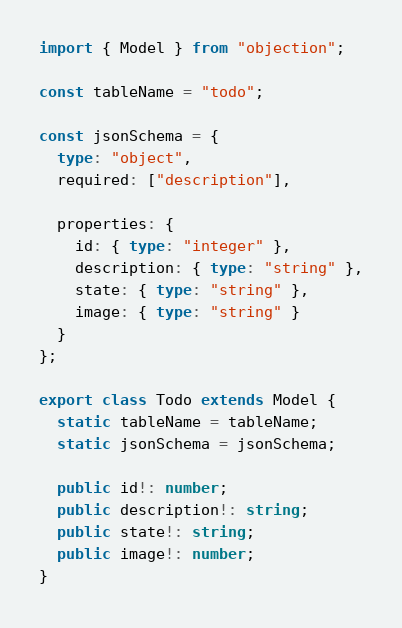<code> <loc_0><loc_0><loc_500><loc_500><_TypeScript_>import { Model } from "objection";

const tableName = "todo";

const jsonSchema = {
  type: "object",
  required: ["description"],

  properties: {
    id: { type: "integer" },
    description: { type: "string" },
    state: { type: "string" },
    image: { type: "string" }
  }
};

export class Todo extends Model {
  static tableName = tableName;
  static jsonSchema = jsonSchema;

  public id!: number;
  public description!: string;
  public state!: string;
  public image!: number;
}
</code> 